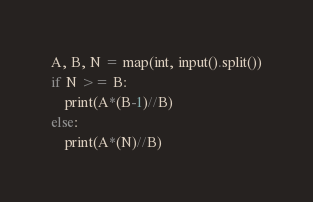<code> <loc_0><loc_0><loc_500><loc_500><_Python_>A, B, N = map(int, input().split())
if N >= B:
    print(A*(B-1)//B)
else:
    print(A*(N)//B)
</code> 